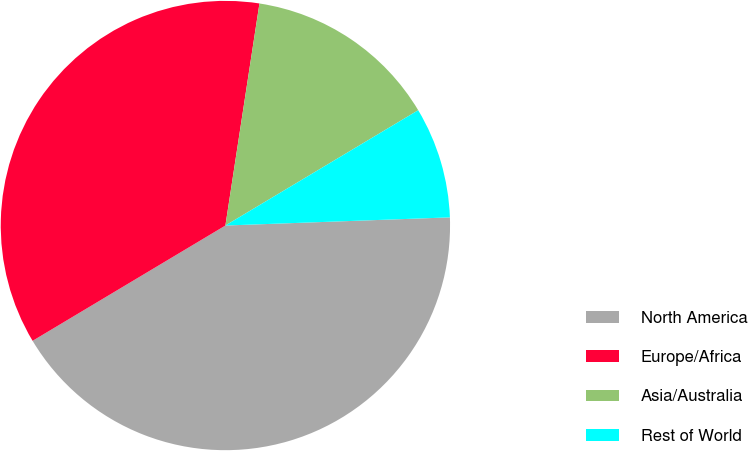Convert chart. <chart><loc_0><loc_0><loc_500><loc_500><pie_chart><fcel>North America<fcel>Europe/Africa<fcel>Asia/Australia<fcel>Rest of World<nl><fcel>42.0%<fcel>36.0%<fcel>14.0%<fcel>8.0%<nl></chart> 